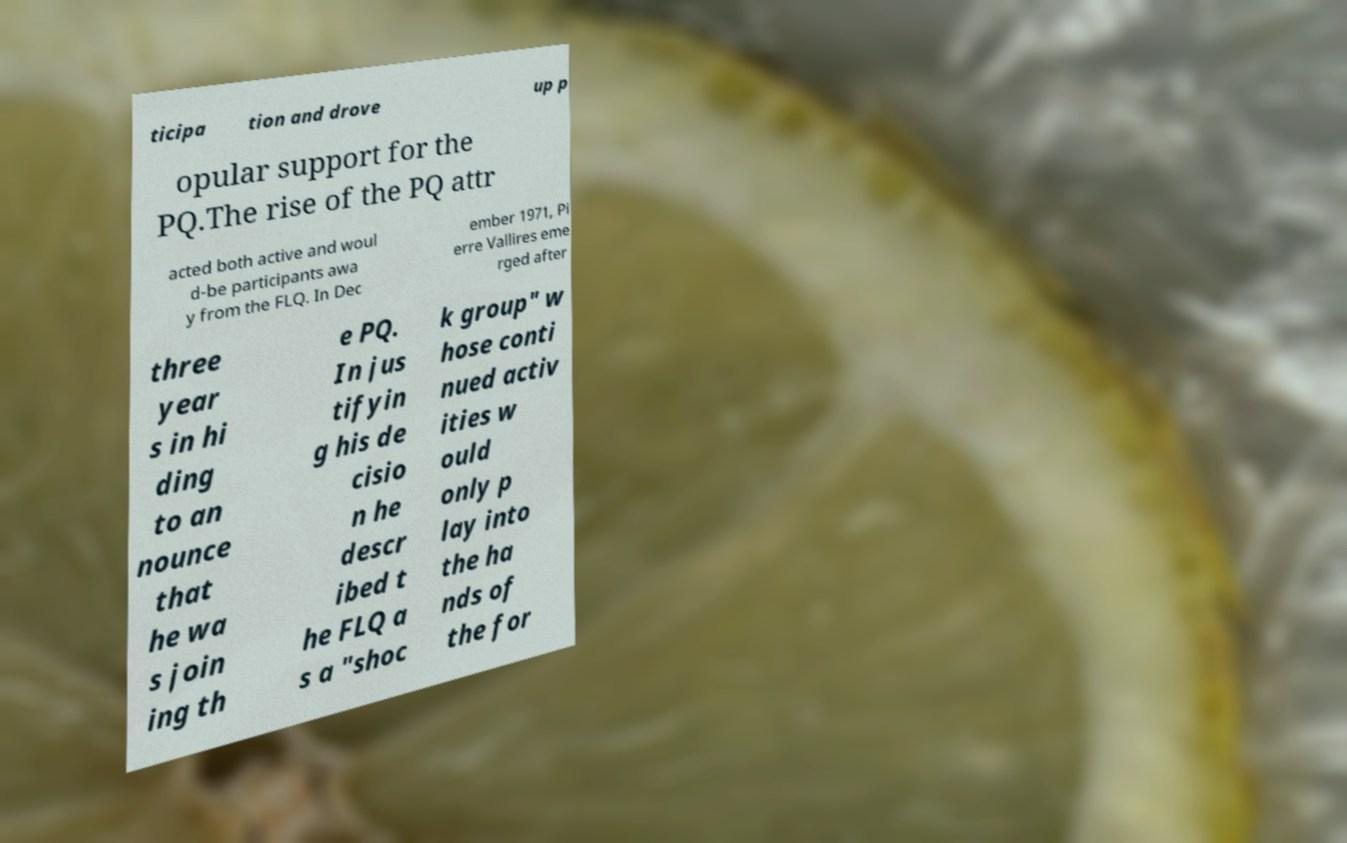Can you read and provide the text displayed in the image?This photo seems to have some interesting text. Can you extract and type it out for me? ticipa tion and drove up p opular support for the PQ.The rise of the PQ attr acted both active and woul d-be participants awa y from the FLQ. In Dec ember 1971, Pi erre Vallires eme rged after three year s in hi ding to an nounce that he wa s join ing th e PQ. In jus tifyin g his de cisio n he descr ibed t he FLQ a s a "shoc k group" w hose conti nued activ ities w ould only p lay into the ha nds of the for 